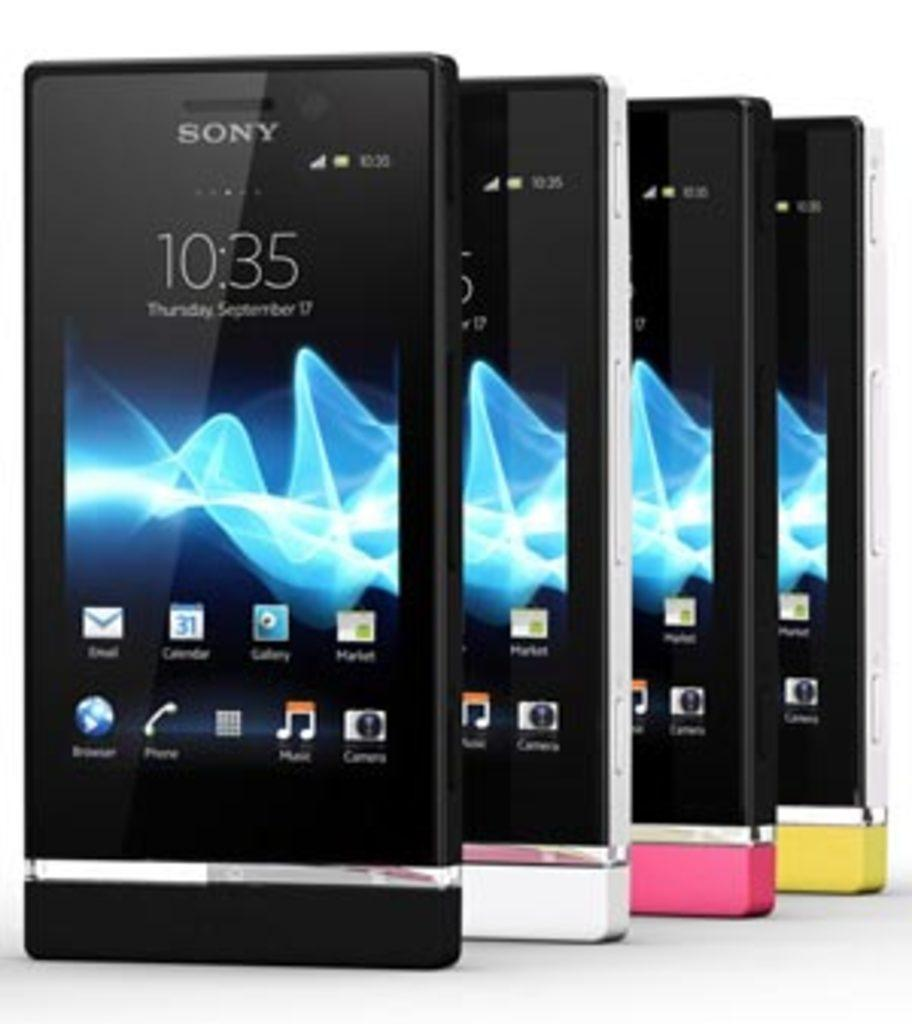<image>
Give a short and clear explanation of the subsequent image. A row of four cellphones that are black, white, pink, and yellow all say Sony on them. 